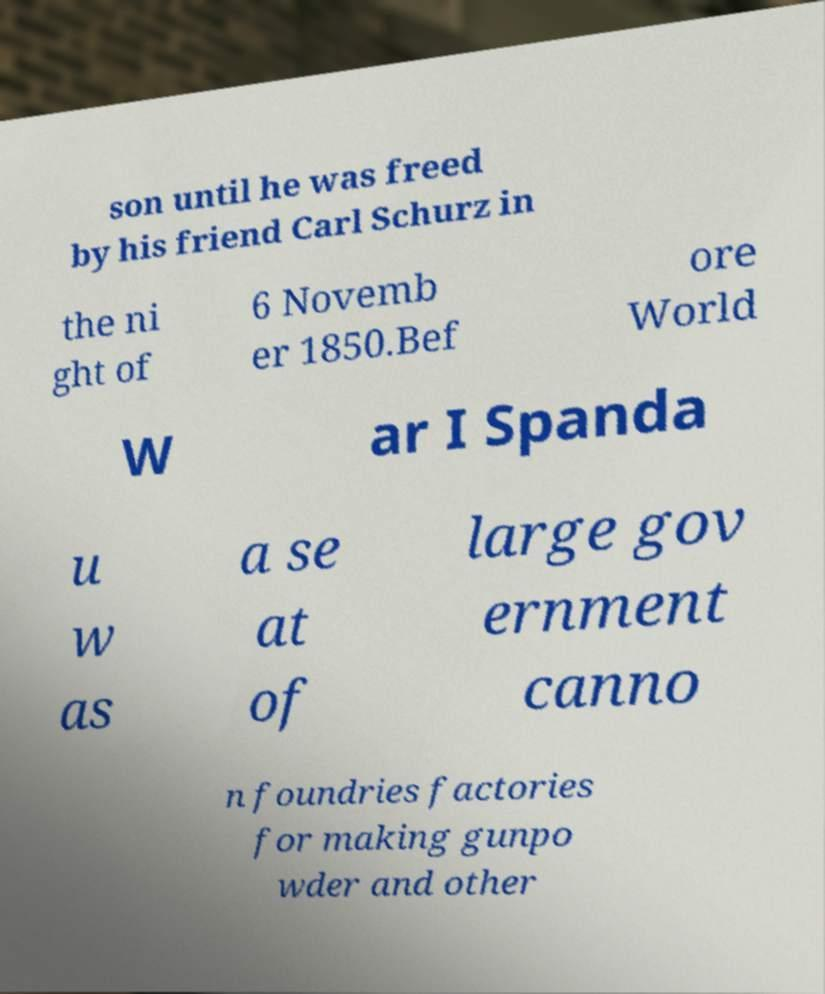For documentation purposes, I need the text within this image transcribed. Could you provide that? son until he was freed by his friend Carl Schurz in the ni ght of 6 Novemb er 1850.Bef ore World W ar I Spanda u w as a se at of large gov ernment canno n foundries factories for making gunpo wder and other 